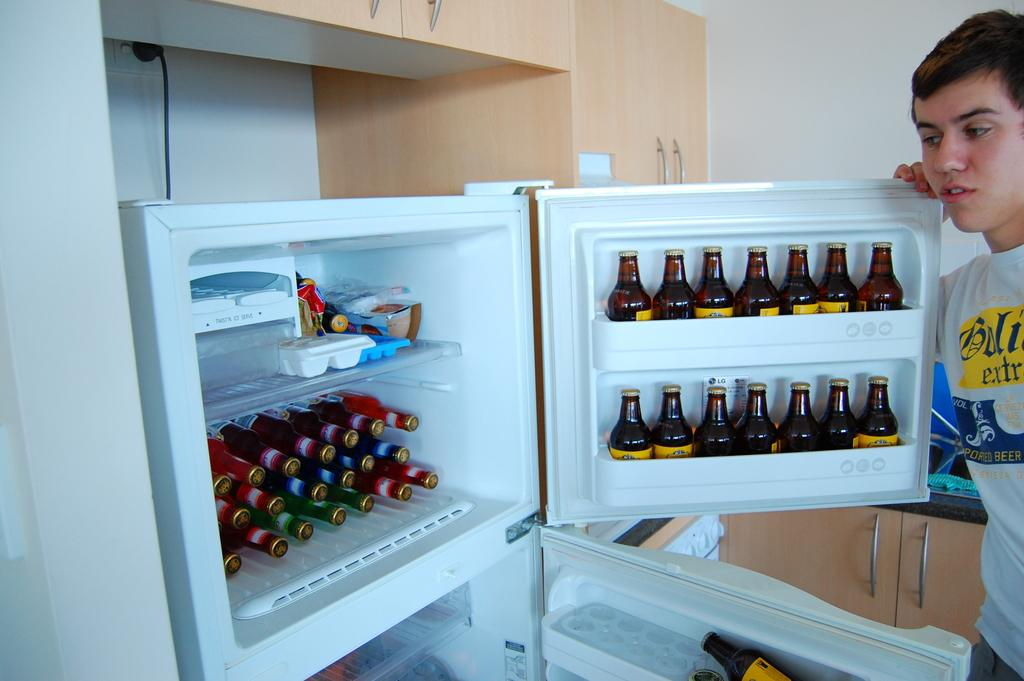Who is present in the image? There is a man in the image. What is the man standing near? The man is standing near a refrigerator. What can be seen inside the refrigerator? There are many bottles inside the refrigerator. What can be seen in the background of the image? There are cabinets and a wall visible in the background of the image. How many cakes is the girl holding in her hands in the image? There is no girl or cakes present in the image. 